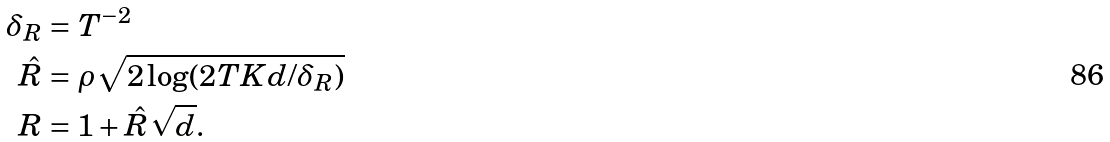<formula> <loc_0><loc_0><loc_500><loc_500>\delta _ { R } & = T ^ { - 2 } \\ \hat { R } & = \rho \sqrt { 2 \log ( 2 T K d / \delta _ { R } ) } \\ R & = 1 + \hat { R } \sqrt { d } .</formula> 